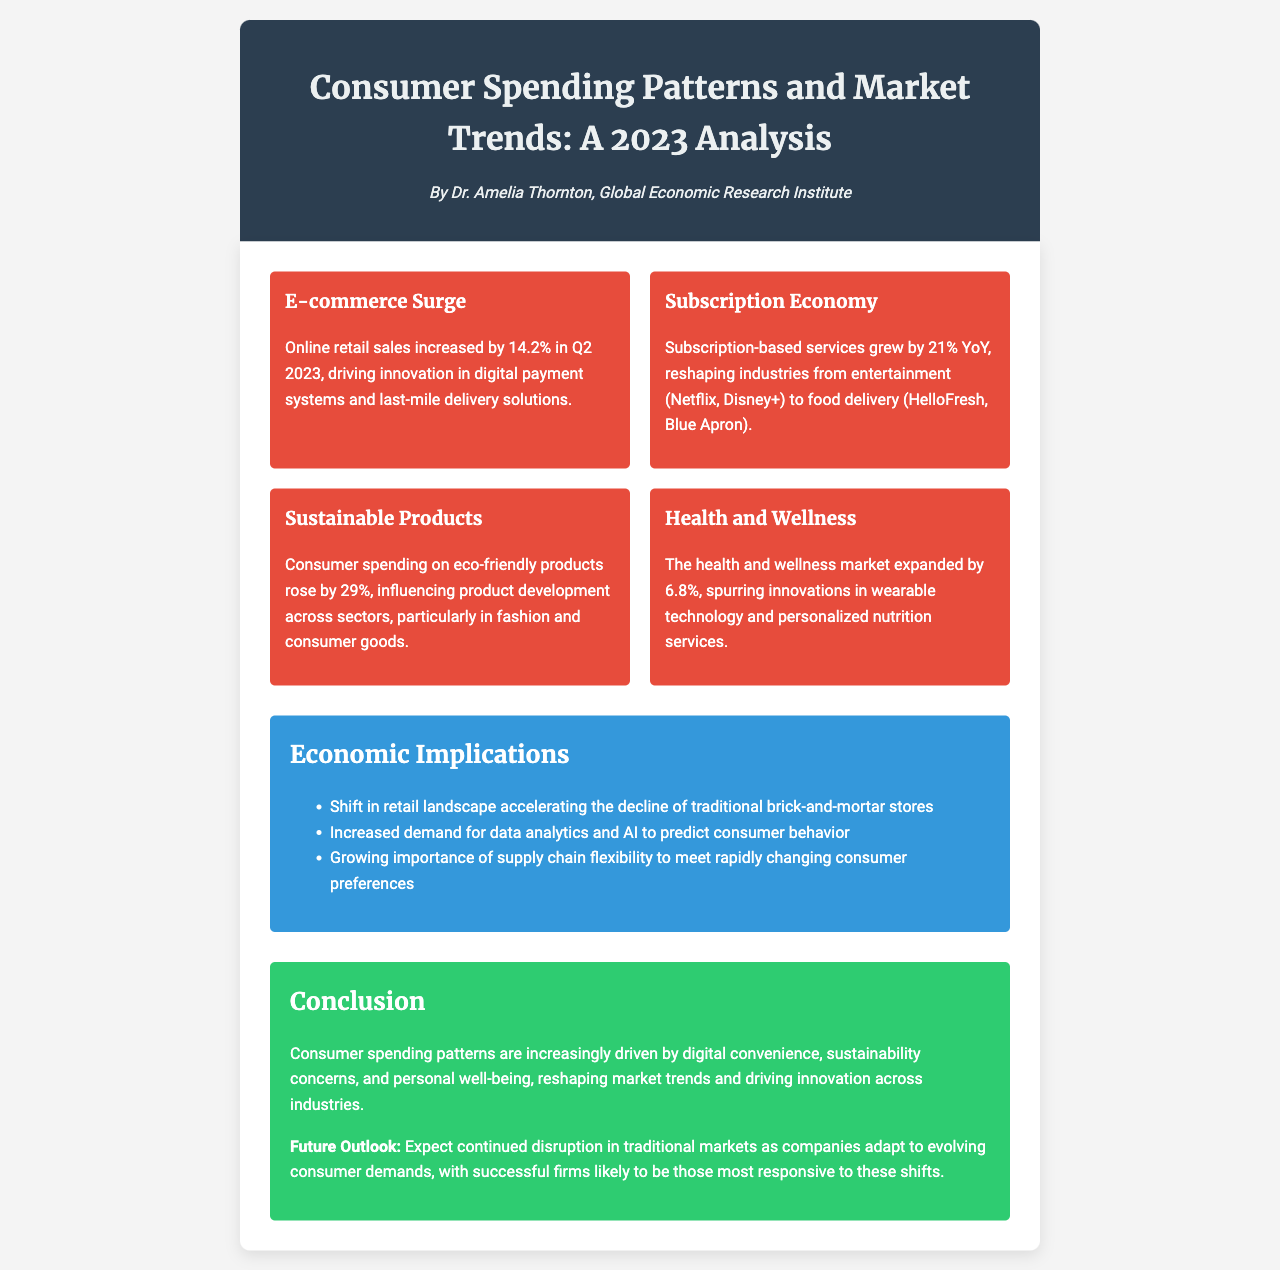What was the increase in online retail sales in Q2 2023? The document states that online retail sales increased by 14.2% in Q2 2023.
Answer: 14.2% Which service sector grew by 21% year-over-year? The document mentions that subscription-based services grew by 21% year-over-year.
Answer: Subscription economy What is the percentage increase in consumer spending on eco-friendly products? The document reports that consumer spending on eco-friendly products rose by 29%.
Answer: 29% How much did the health and wellness market expand by? The document indicates that the health and wellness market expanded by 6.8%.
Answer: 6.8% What are the key drivers of recent consumer spending patterns according to the conclusion? The document concludes that consumer spending patterns are driven by digital convenience, sustainability concerns, and personal well-being.
Answer: Digital convenience, sustainability concerns, personal well-being What implication is mentioned regarding traditional brick-and-mortar stores? The document notes a shift in the retail landscape accelerating the decline of traditional brick-and-mortar stores.
Answer: Decline of traditional brick-and-mortar stores What type of technology is increasingly demanded according to the implications section? The document highlights the increased demand for data analytics and AI to predict consumer behavior.
Answer: Data analytics and AI What does the future outlook suggest about traditional markets? The document states that traditional markets will experience continued disruption as companies adapt to evolving consumer demands.
Answer: Continued disruption in traditional markets 